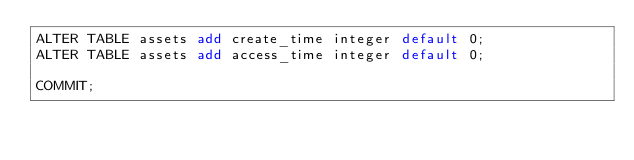<code> <loc_0><loc_0><loc_500><loc_500><_SQL_>ALTER TABLE assets add create_time integer default 0;
ALTER TABLE assets add access_time integer default 0;

COMMIT;
</code> 